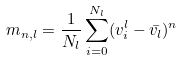Convert formula to latex. <formula><loc_0><loc_0><loc_500><loc_500>m _ { n , l } = \frac { 1 } { N _ { l } } \sum _ { i = 0 } ^ { N _ { l } } ( v _ { i } ^ { l } - \bar { v _ { l } } ) ^ { n }</formula> 